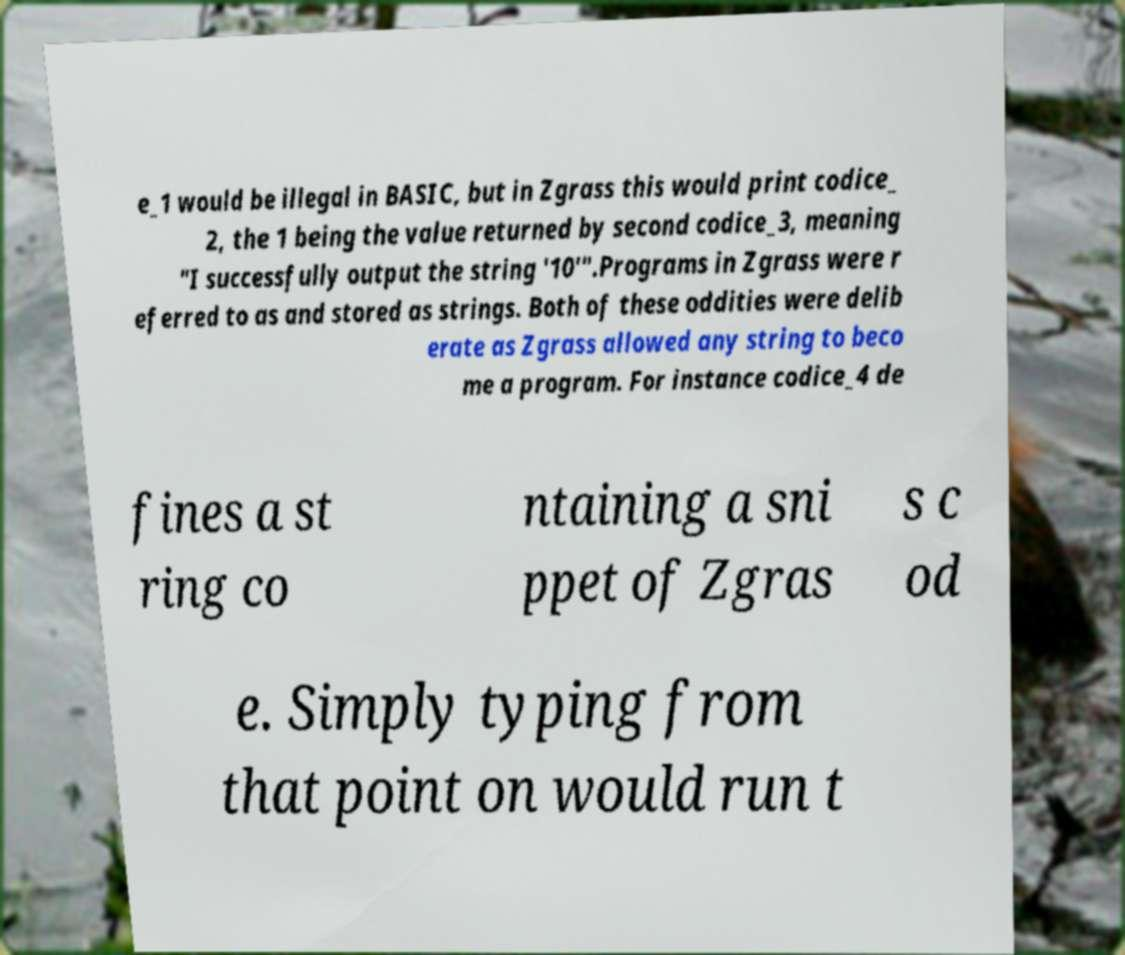Please read and relay the text visible in this image. What does it say? e_1 would be illegal in BASIC, but in Zgrass this would print codice_ 2, the 1 being the value returned by second codice_3, meaning "I successfully output the string '10'".Programs in Zgrass were r eferred to as and stored as strings. Both of these oddities were delib erate as Zgrass allowed any string to beco me a program. For instance codice_4 de fines a st ring co ntaining a sni ppet of Zgras s c od e. Simply typing from that point on would run t 